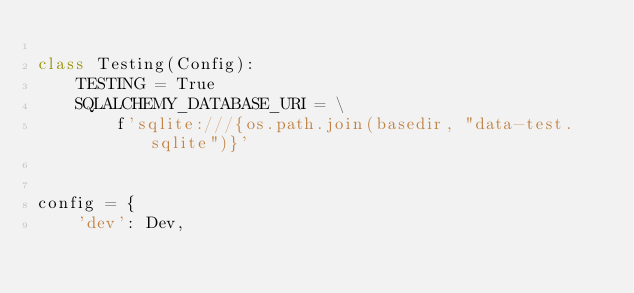Convert code to text. <code><loc_0><loc_0><loc_500><loc_500><_Python_>
class Testing(Config):
    TESTING = True
    SQLALCHEMY_DATABASE_URI = \
        f'sqlite:///{os.path.join(basedir, "data-test.sqlite")}'


config = {
    'dev': Dev,</code> 